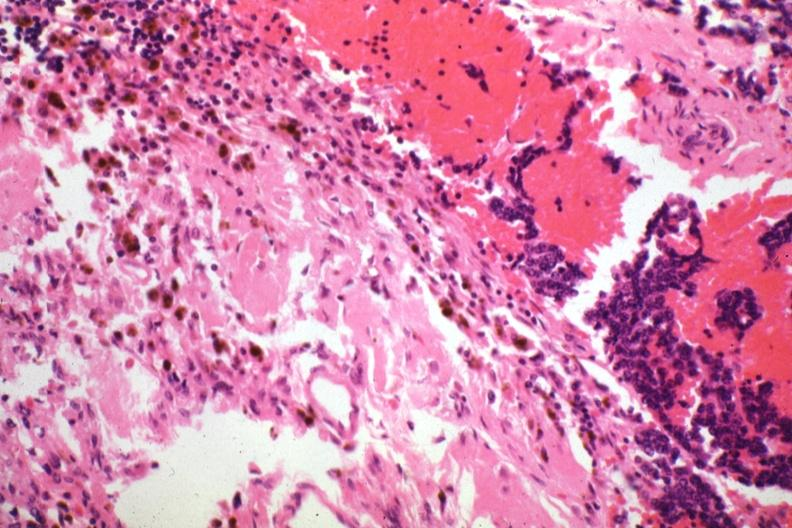does this image show tissue about tumor with tumor cells?
Answer the question using a single word or phrase. Yes 